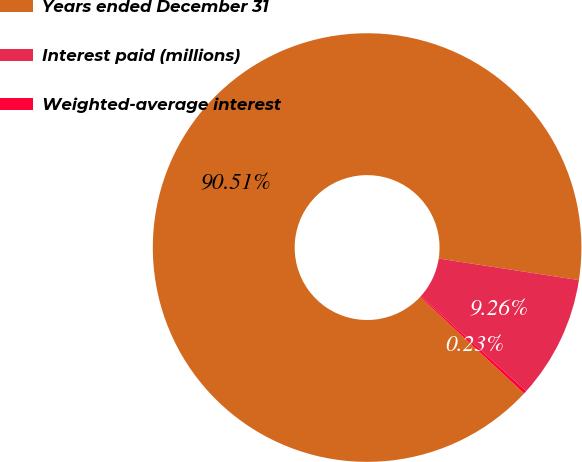<chart> <loc_0><loc_0><loc_500><loc_500><pie_chart><fcel>Years ended December 31<fcel>Interest paid (millions)<fcel>Weighted-average interest<nl><fcel>90.51%<fcel>9.26%<fcel>0.23%<nl></chart> 